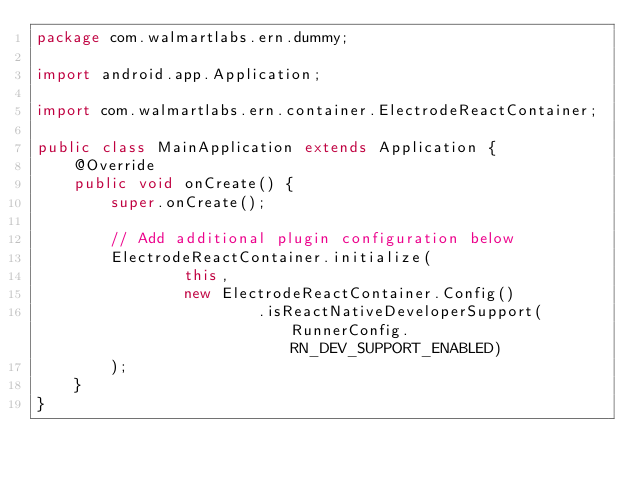<code> <loc_0><loc_0><loc_500><loc_500><_Java_>package com.walmartlabs.ern.dummy;

import android.app.Application;

import com.walmartlabs.ern.container.ElectrodeReactContainer;

public class MainApplication extends Application {
    @Override
    public void onCreate() {
        super.onCreate();

        // Add additional plugin configuration below
        ElectrodeReactContainer.initialize(
                this,
                new ElectrodeReactContainer.Config()
                        .isReactNativeDeveloperSupport(RunnerConfig.RN_DEV_SUPPORT_ENABLED)
        );
    }
}
</code> 